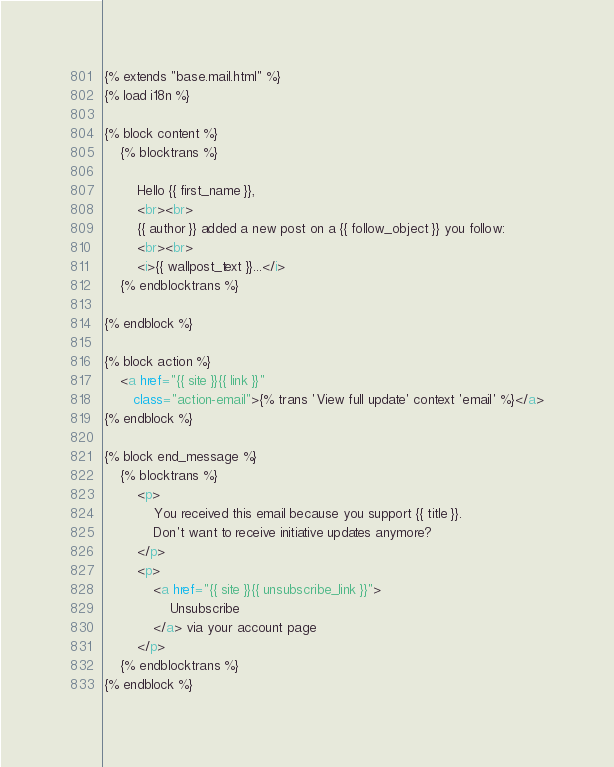<code> <loc_0><loc_0><loc_500><loc_500><_HTML_>{% extends "base.mail.html" %}
{% load i18n %}

{% block content %}
    {% blocktrans %}

        Hello {{ first_name }},
        <br><br>
        {{ author }} added a new post on a {{ follow_object }} you follow:
        <br><br>
        <i>{{ wallpost_text }}...</i>
    {% endblocktrans %}

{% endblock %}

{% block action %}
    <a href="{{ site }}{{ link }}"
       class="action-email">{% trans 'View full update' context 'email' %}</a>
{% endblock %}

{% block end_message %}
    {% blocktrans %}
        <p>
            You received this email because you support {{ title }}.
            Don't want to receive initiative updates anymore?
        </p>
        <p>
            <a href="{{ site }}{{ unsubscribe_link }}">
                Unsubscribe
            </a> via your account page
        </p>
    {% endblocktrans %}
{% endblock %}
</code> 